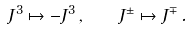Convert formula to latex. <formula><loc_0><loc_0><loc_500><loc_500>J ^ { 3 } \mapsto - J ^ { 3 } \, , \quad J ^ { \pm } \mapsto J ^ { \mp } \, .</formula> 